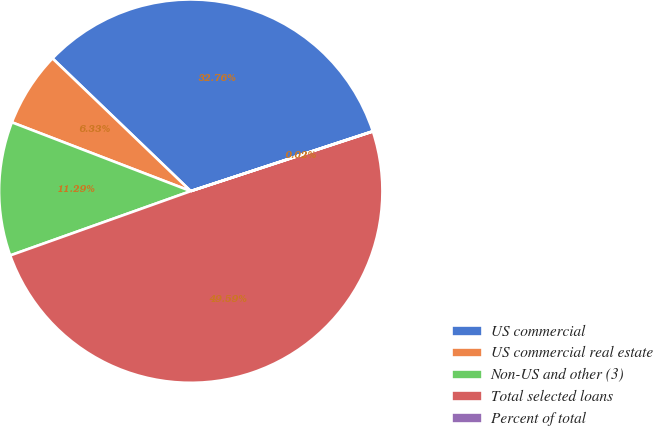Convert chart. <chart><loc_0><loc_0><loc_500><loc_500><pie_chart><fcel>US commercial<fcel>US commercial real estate<fcel>Non-US and other (3)<fcel>Total selected loans<fcel>Percent of total<nl><fcel>32.76%<fcel>6.33%<fcel>11.29%<fcel>49.59%<fcel>0.02%<nl></chart> 